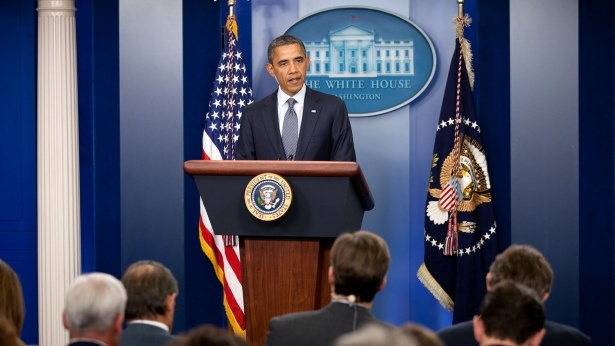Describe the objects in this image and their specific colors. I can see people in black, brown, and white tones, people in black, maroon, and gray tones, people in black, maroon, and gray tones, people in black, darkgray, gray, tan, and maroon tones, and people in black, gray, and maroon tones in this image. 